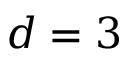<formula> <loc_0><loc_0><loc_500><loc_500>d = 3</formula> 